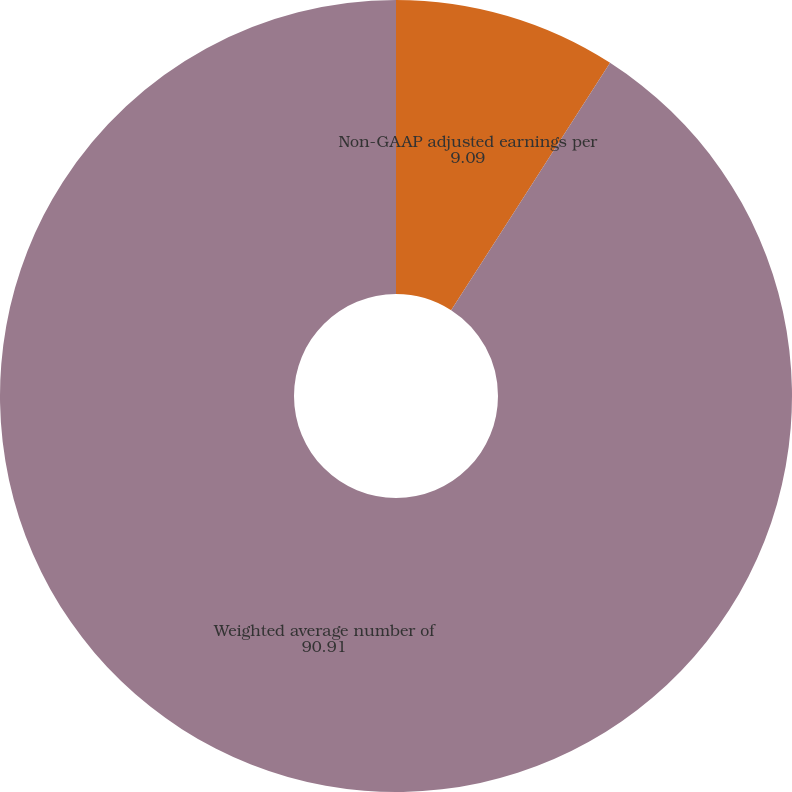<chart> <loc_0><loc_0><loc_500><loc_500><pie_chart><fcel>Reinstatement of federal R&D<fcel>Non-GAAP adjusted earnings per<fcel>Weighted average number of<nl><fcel>0.0%<fcel>9.09%<fcel>90.91%<nl></chart> 